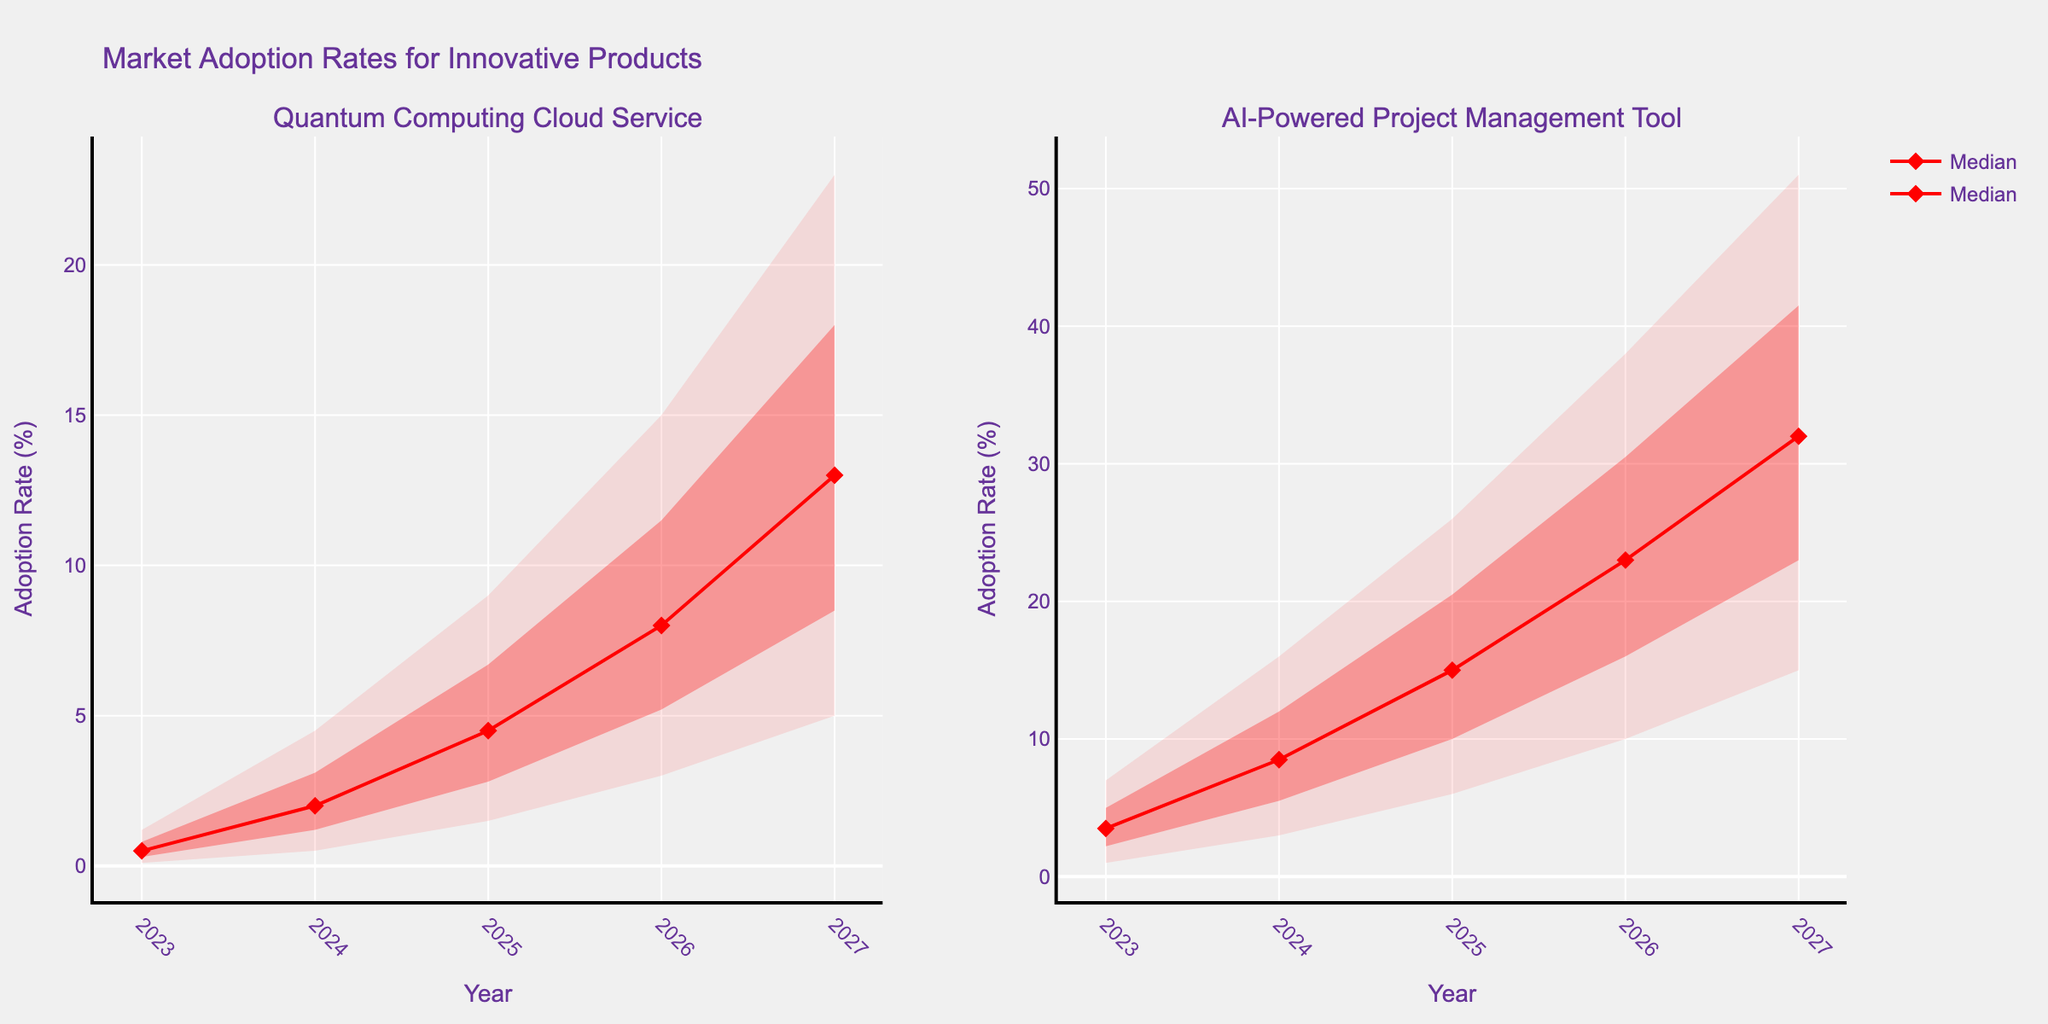what is the title of the figure? the title is located at the top of the figure. it says "market adoption rates for innovative products".
Answer: market adoption rates for innovative products which product shows higher adoption rates in 2025 according to the median values? look at the median lines in 2025 for both products. the ai-powered project management tool has a median value of 15%, while the quantum computing cloud service has 4.5%.
Answer: ai-powered project management tool how does the adoption rate range for the ai-powered project management tool grow from 2023 to 2027? observe the filled areas for the ai-powered project management tool from 2023 to 2027. the range starts at (1.0-7.0)% in 2023 and expands to (15.0-51.0)% in 2027.
Answer: from 1.0-7.0% to 15.0-51.0% in 2026, which product has a smaller uncertainty range? compare the width of the filled areas in 2026. the quantum computing cloud service ranges from 3% to 15%, whereas the ai-powered project management tool ranges from 10% to 38%.
Answer: quantum computing cloud service what's the expected adoption growth (using median) for the quantum computing cloud service from 2023 to 2026? check the median values for the quantum computing cloud service: it's 0.5% in 2023 and 8.0% in 2026. calculate the growth (8.0% - 0.5%).
Answer: 7.5% which year has the highest adoption rate for both products? find the highest adoption rates by looking at the top of the highest uncertainty area for each product. for both products, this is in 2027.
Answer: 2027 considering 2024, compare the high adoption rate estimation between the two products? in 2024, the high adoption for the quantum computing cloud service is 4.5%, whereas for the ai-powered project management tool it is 16%.
Answer: ai-powered project management tool how consistent is the adoption rate growth for the ai-powered project management tool as compared to the quantum computing cloud service? examine the median lines for both products. the ai-powered project management tool shows a steadier, more linear growth compared to the more exponential growth of the quantum computing cloud service.
Answer: ai-powered project management tool what is the adoption rate for the ai-powered project management tool expected to exceed 20%? the median adoption rate of the ai-powered project management tool exceeds 20% in 2025.
Answer: 2025 